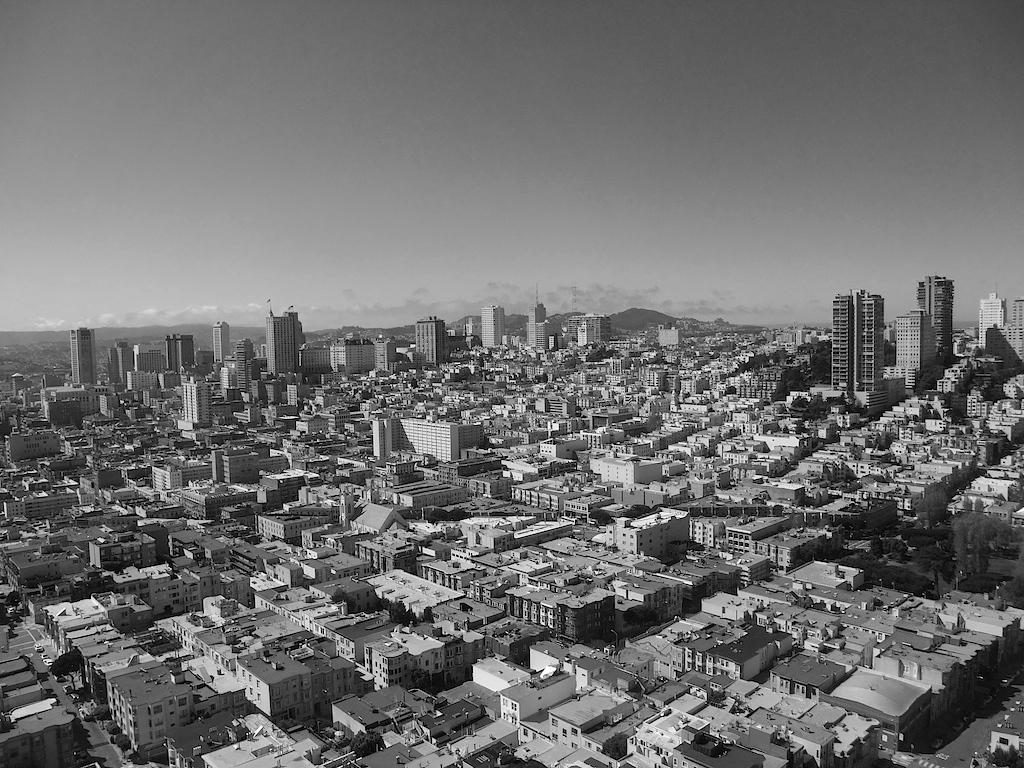What type of structures can be seen in the image? There are houses and buildings in the image. What can be found between the houses and buildings? There are roads in the image. Can you see a stamp on any of the houses in the image? There is no stamp visible on any of the houses in the image. Are there any geese walking on the roads in the image? There are no geese present in the image. 